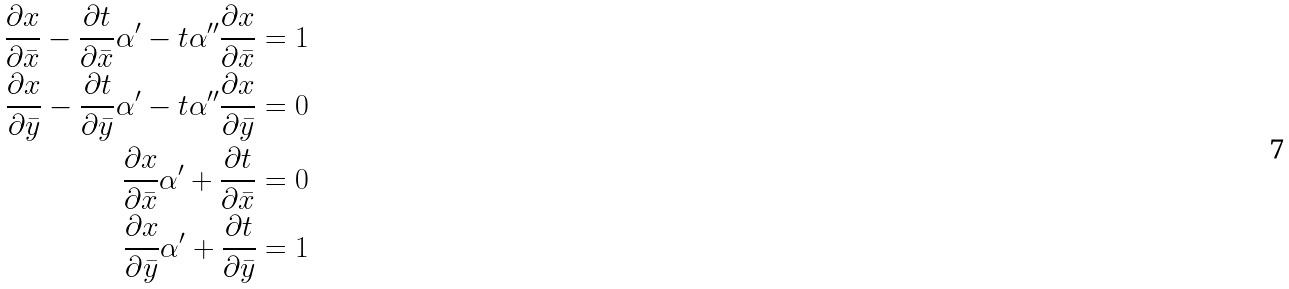Convert formula to latex. <formula><loc_0><loc_0><loc_500><loc_500>\frac { \partial x } { \partial \bar { x } } - \frac { \partial t } { \partial \bar { x } } \alpha ^ { \prime } - t \alpha ^ { \prime \prime } \frac { \partial x } { \partial \bar { x } } = 1 \\ \frac { \partial x } { \partial \bar { y } } - \frac { \partial t } { \partial \bar { y } } \alpha ^ { \prime } - t \alpha ^ { \prime \prime } \frac { \partial x } { \partial \bar { y } } = 0 \\ \frac { \partial x } { \partial \bar { x } } \alpha ^ { \prime } + \frac { \partial t } { \partial \bar { x } } = 0 \\ \frac { \partial x } { \partial \bar { y } } \alpha ^ { \prime } + \frac { \partial t } { \partial \bar { y } } = 1</formula> 